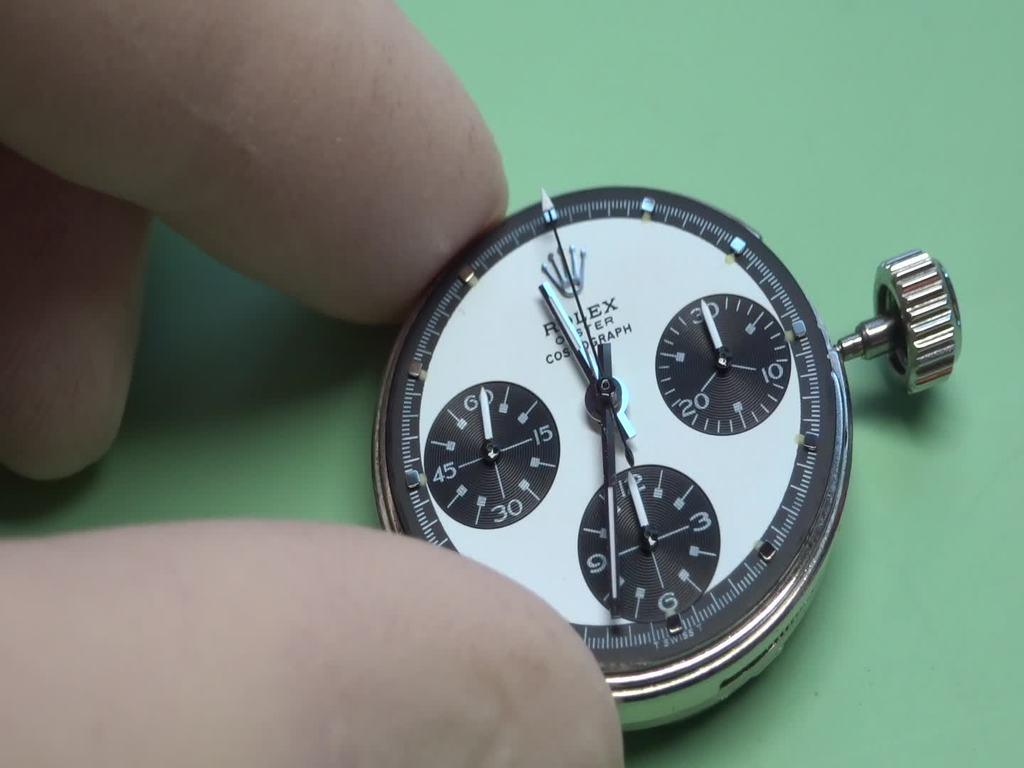<image>
Create a compact narrative representing the image presented. A person is touching a pocket watch that says Rolex. 